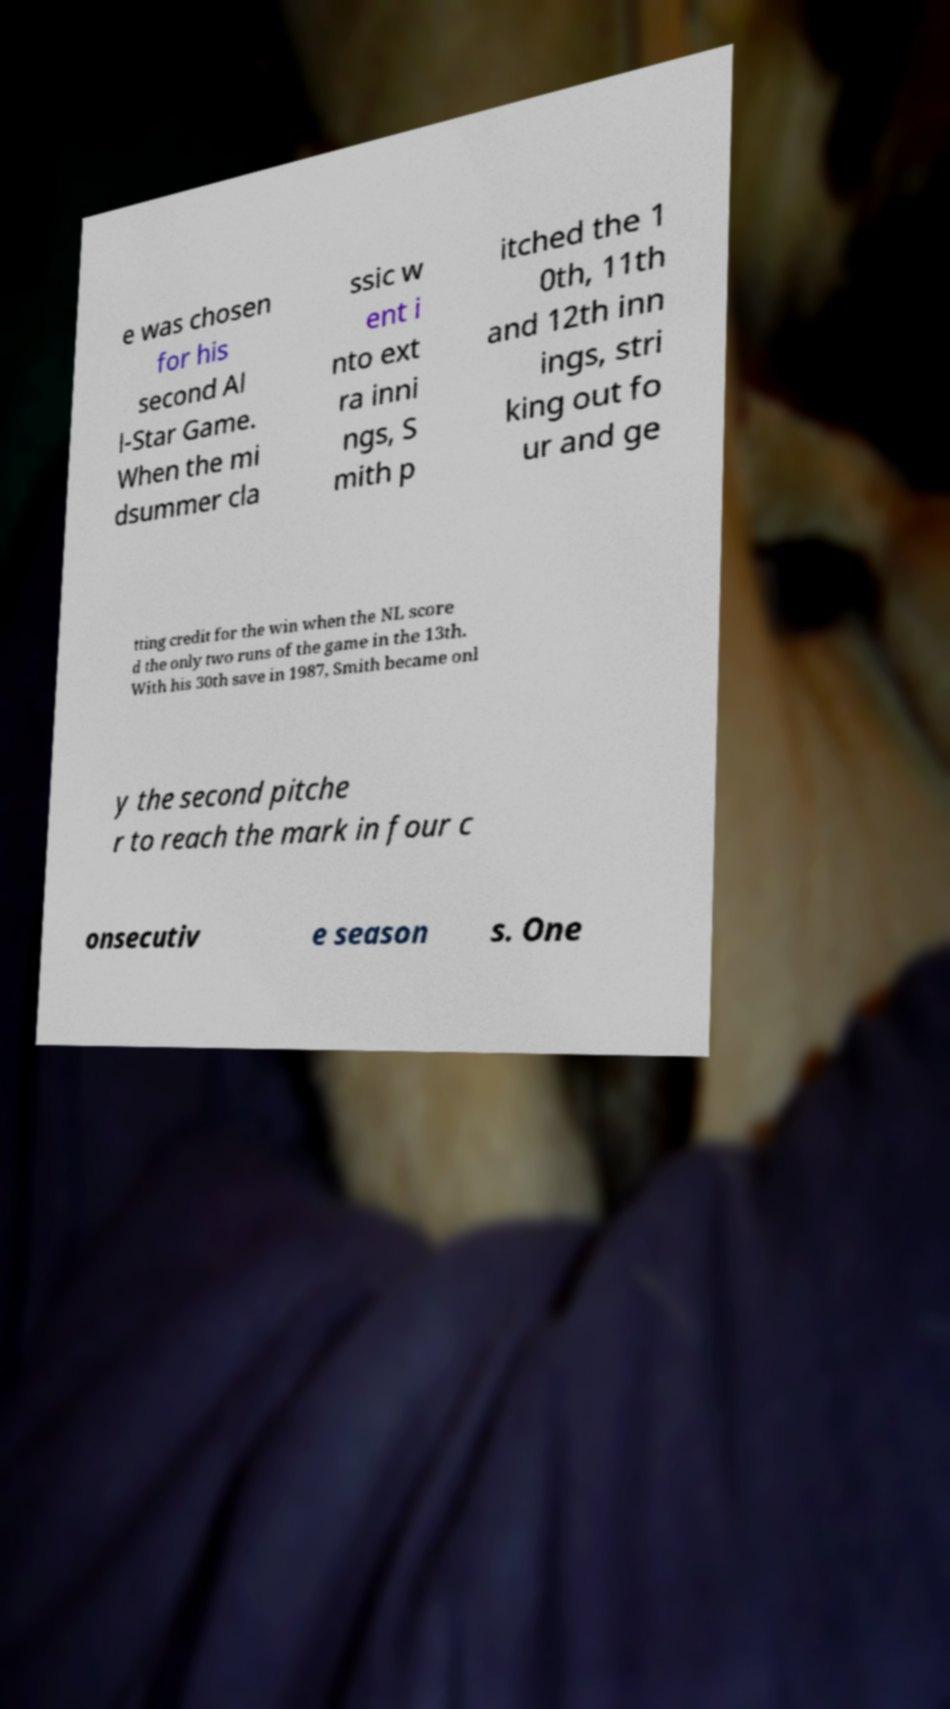Could you extract and type out the text from this image? e was chosen for his second Al l-Star Game. When the mi dsummer cla ssic w ent i nto ext ra inni ngs, S mith p itched the 1 0th, 11th and 12th inn ings, stri king out fo ur and ge tting credit for the win when the NL score d the only two runs of the game in the 13th. With his 30th save in 1987, Smith became onl y the second pitche r to reach the mark in four c onsecutiv e season s. One 